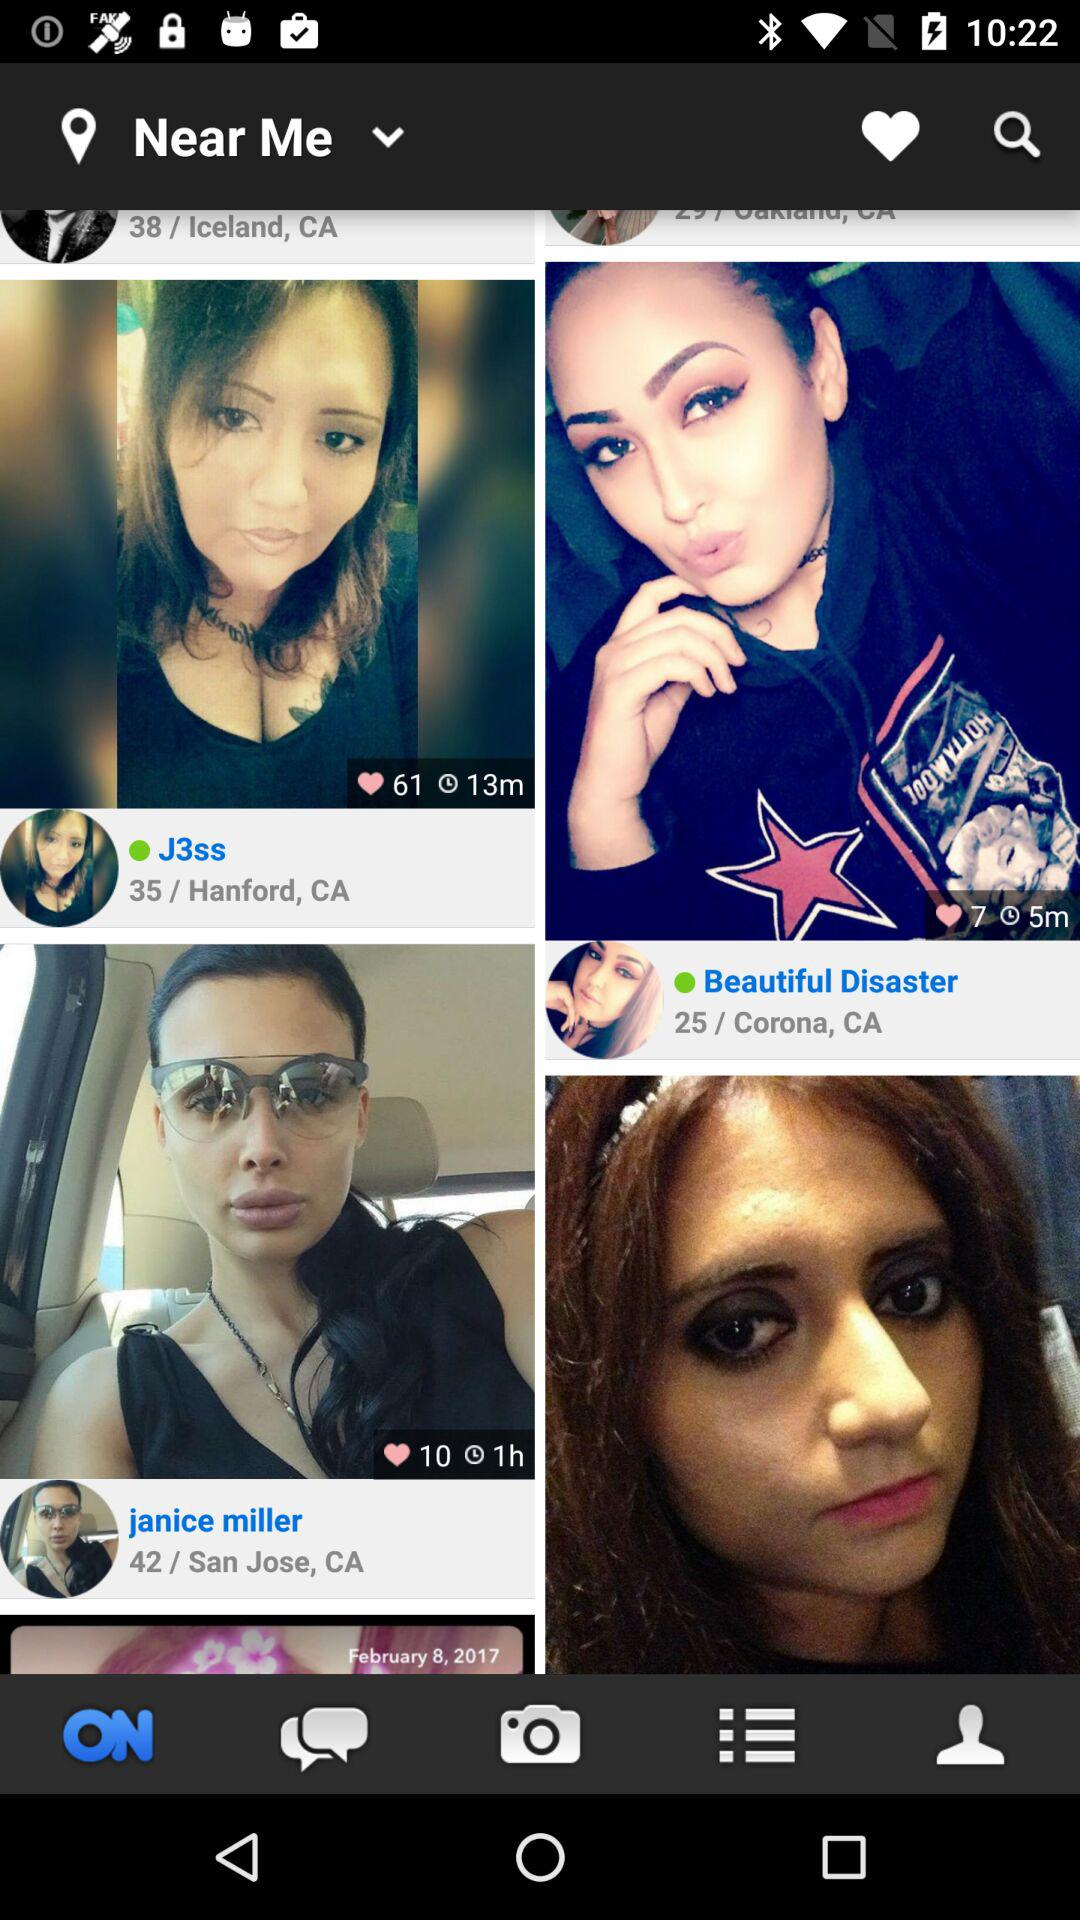Where is Janice Miller from? Janice Miller is from San Jose, CA. 